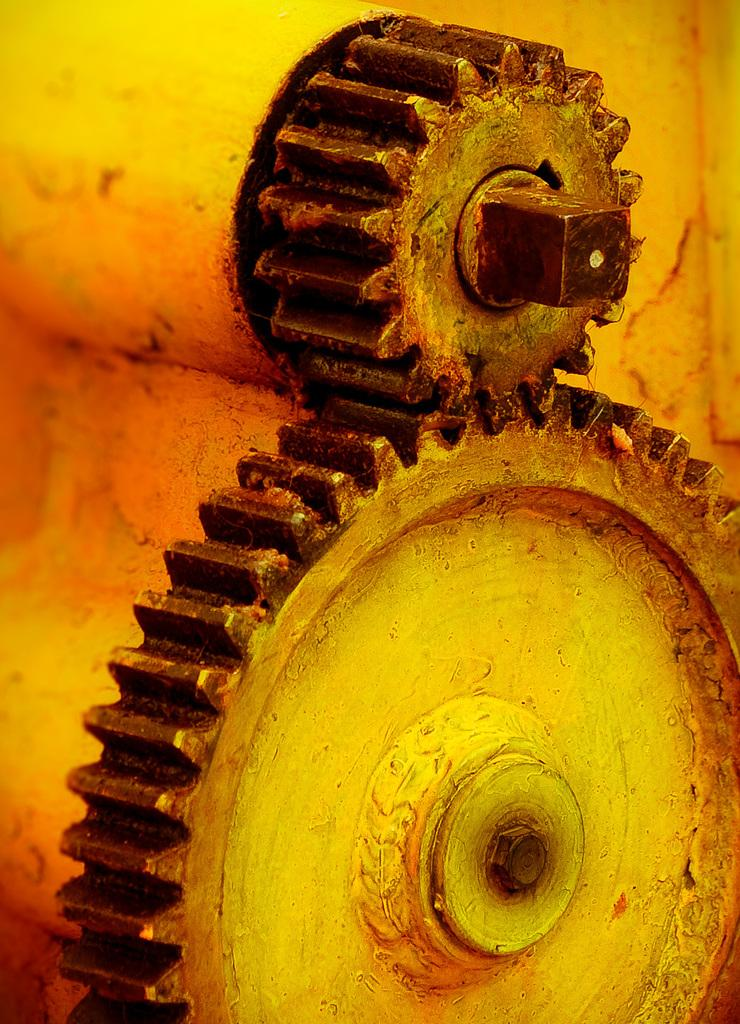What type of objects are present in the image? There are metal gears in the image. Can you describe the material of the objects? The objects are made of metal. What might these metal gears be used for? Metal gears are often used in machinery or mechanical systems. What type of steam can be seen coming from the gears in the image? There is no steam present in the image; it only features metal gears. 